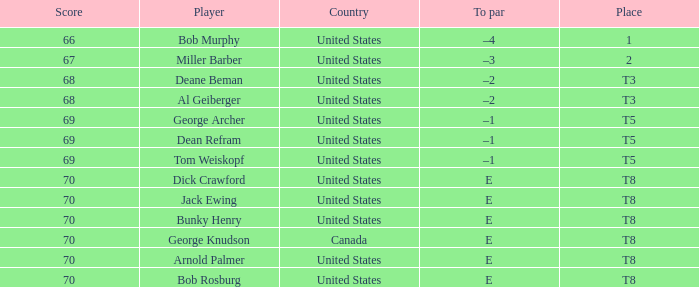When Bunky Henry of the United States scored higher than 67 and his To par was e, what was his place? T8. 